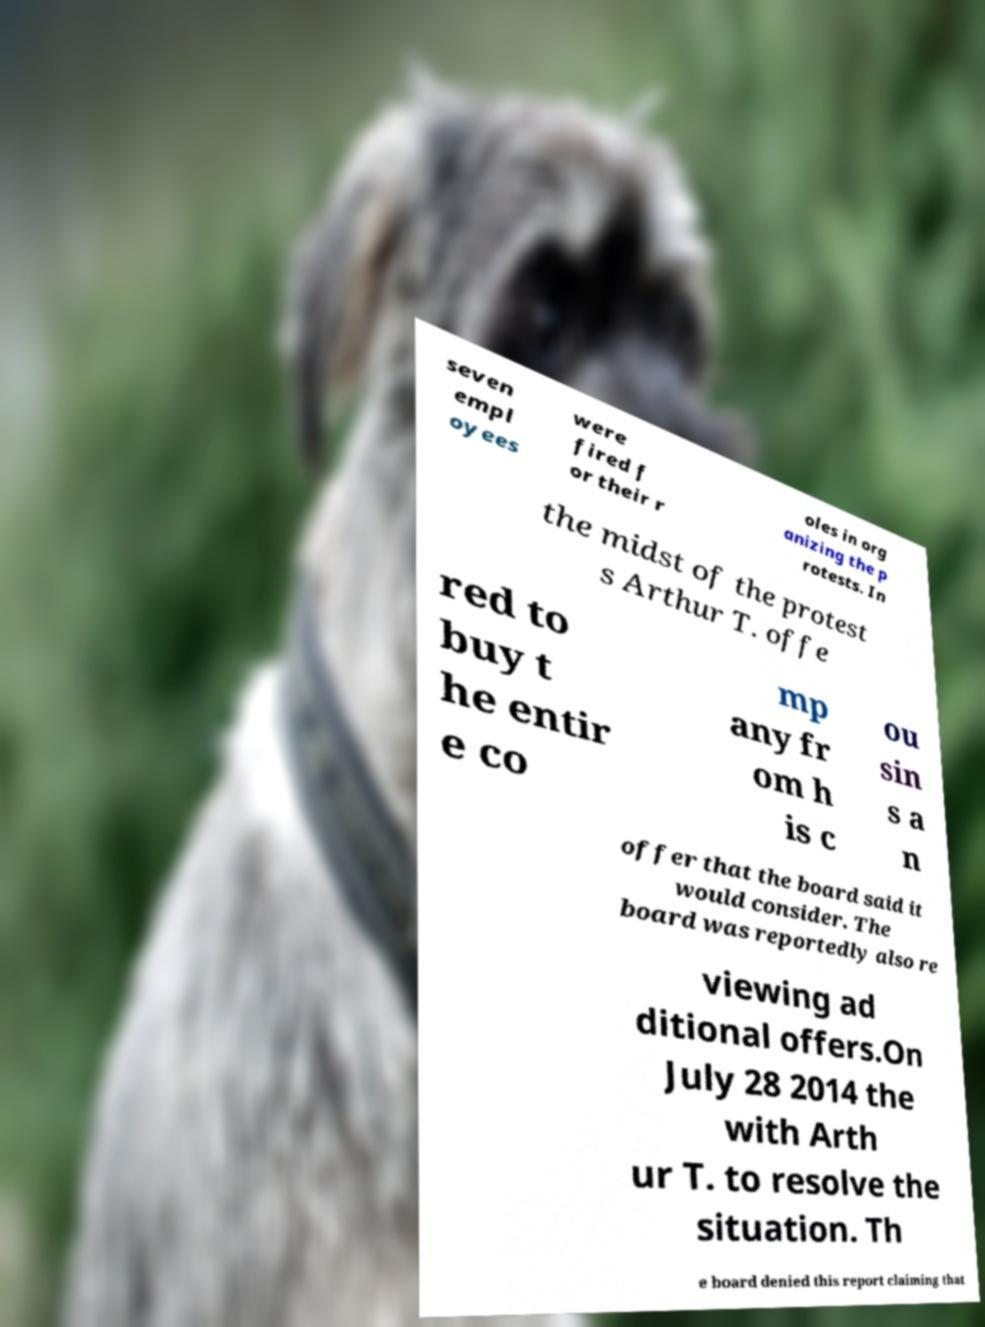Can you accurately transcribe the text from the provided image for me? seven empl oyees were fired f or their r oles in org anizing the p rotests. In the midst of the protest s Arthur T. offe red to buy t he entir e co mp any fr om h is c ou sin s a n offer that the board said it would consider. The board was reportedly also re viewing ad ditional offers.On July 28 2014 the with Arth ur T. to resolve the situation. Th e board denied this report claiming that 